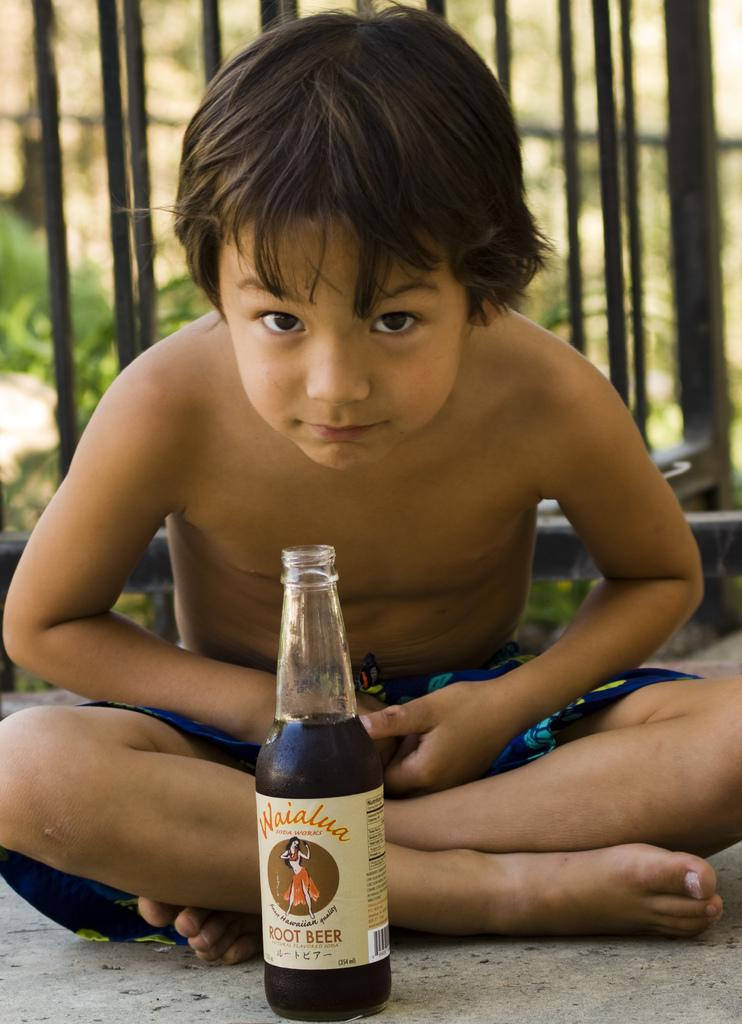What is the main subject of the image? The main subject of the image is a kid. What is the kid doing in the image? The kid is sitting in the image. What object is in front of the kid? There is a wine bottle in front of the kid. What type of vegetation can be seen in the image? There are plants visible in the image. What architectural features are present in the image? There are poles in the image. Can you see a boat floating on a lake in the image? No, there is no boat or lake present in the image. What type of fruit is being served with the wine in the image? There is no fruit visible in the image, and the wine bottle is not being served with any food. 